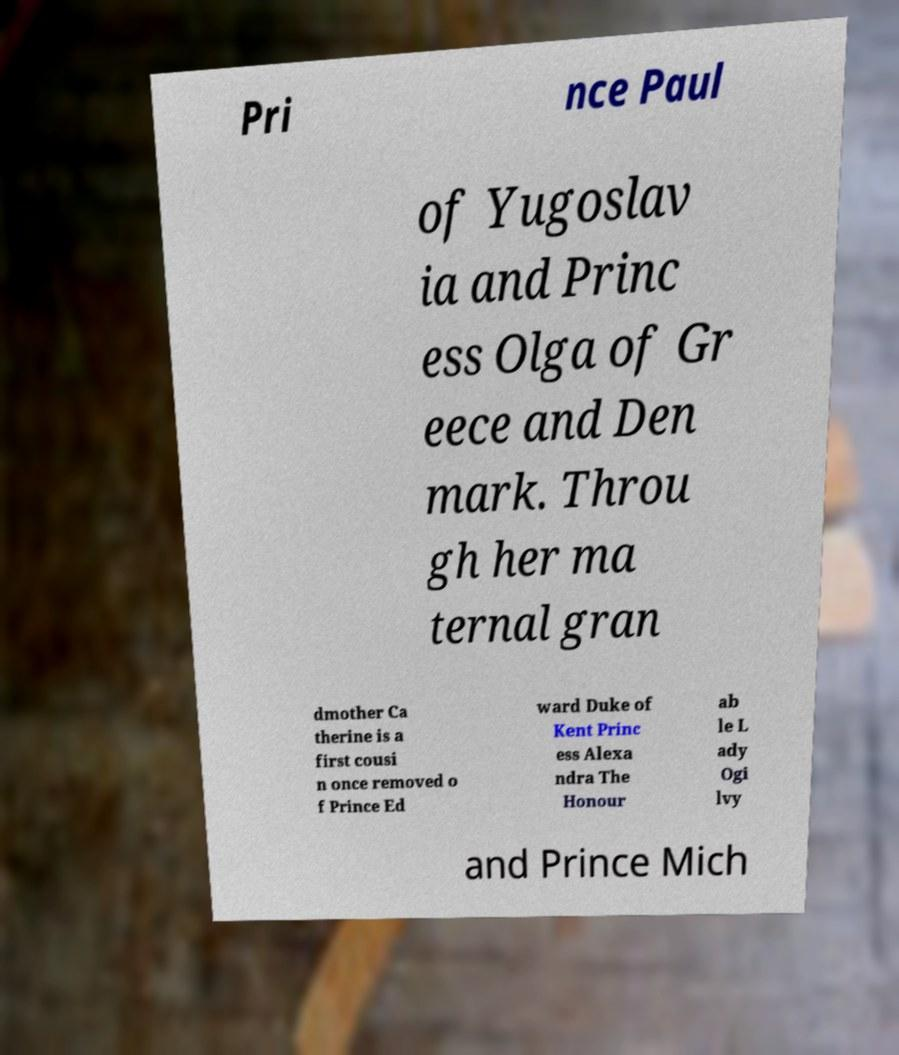Could you extract and type out the text from this image? Pri nce Paul of Yugoslav ia and Princ ess Olga of Gr eece and Den mark. Throu gh her ma ternal gran dmother Ca therine is a first cousi n once removed o f Prince Ed ward Duke of Kent Princ ess Alexa ndra The Honour ab le L ady Ogi lvy and Prince Mich 